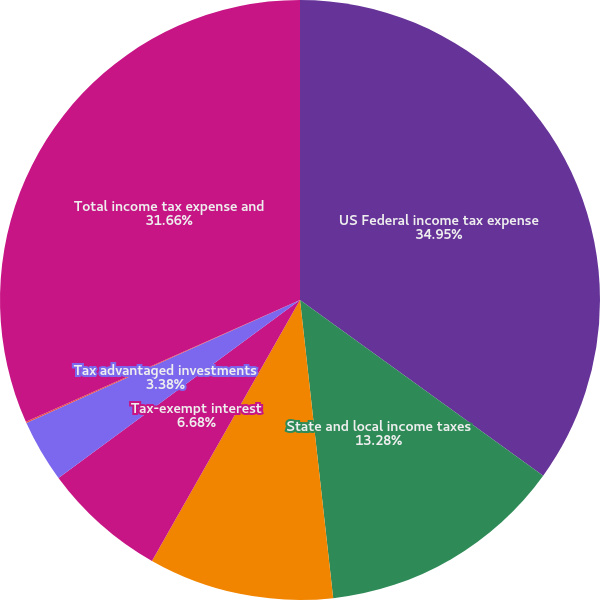Convert chart to OTSL. <chart><loc_0><loc_0><loc_500><loc_500><pie_chart><fcel>US Federal income tax expense<fcel>State and local income taxes<fcel>Bank-owned life insurance<fcel>Tax-exempt interest<fcel>Tax advantaged investments<fcel>Other<fcel>Total income tax expense and<nl><fcel>34.96%<fcel>13.28%<fcel>9.98%<fcel>6.68%<fcel>3.38%<fcel>0.07%<fcel>31.66%<nl></chart> 